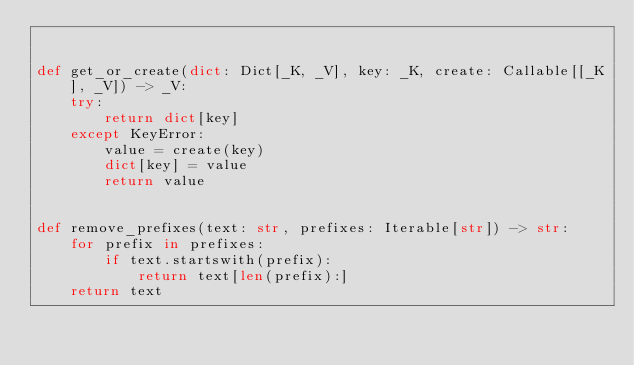Convert code to text. <code><loc_0><loc_0><loc_500><loc_500><_Python_>

def get_or_create(dict: Dict[_K, _V], key: _K, create: Callable[[_K], _V]) -> _V:
    try:
        return dict[key]
    except KeyError:
        value = create(key)
        dict[key] = value
        return value


def remove_prefixes(text: str, prefixes: Iterable[str]) -> str:
    for prefix in prefixes:
        if text.startswith(prefix):
            return text[len(prefix):]
    return text
</code> 